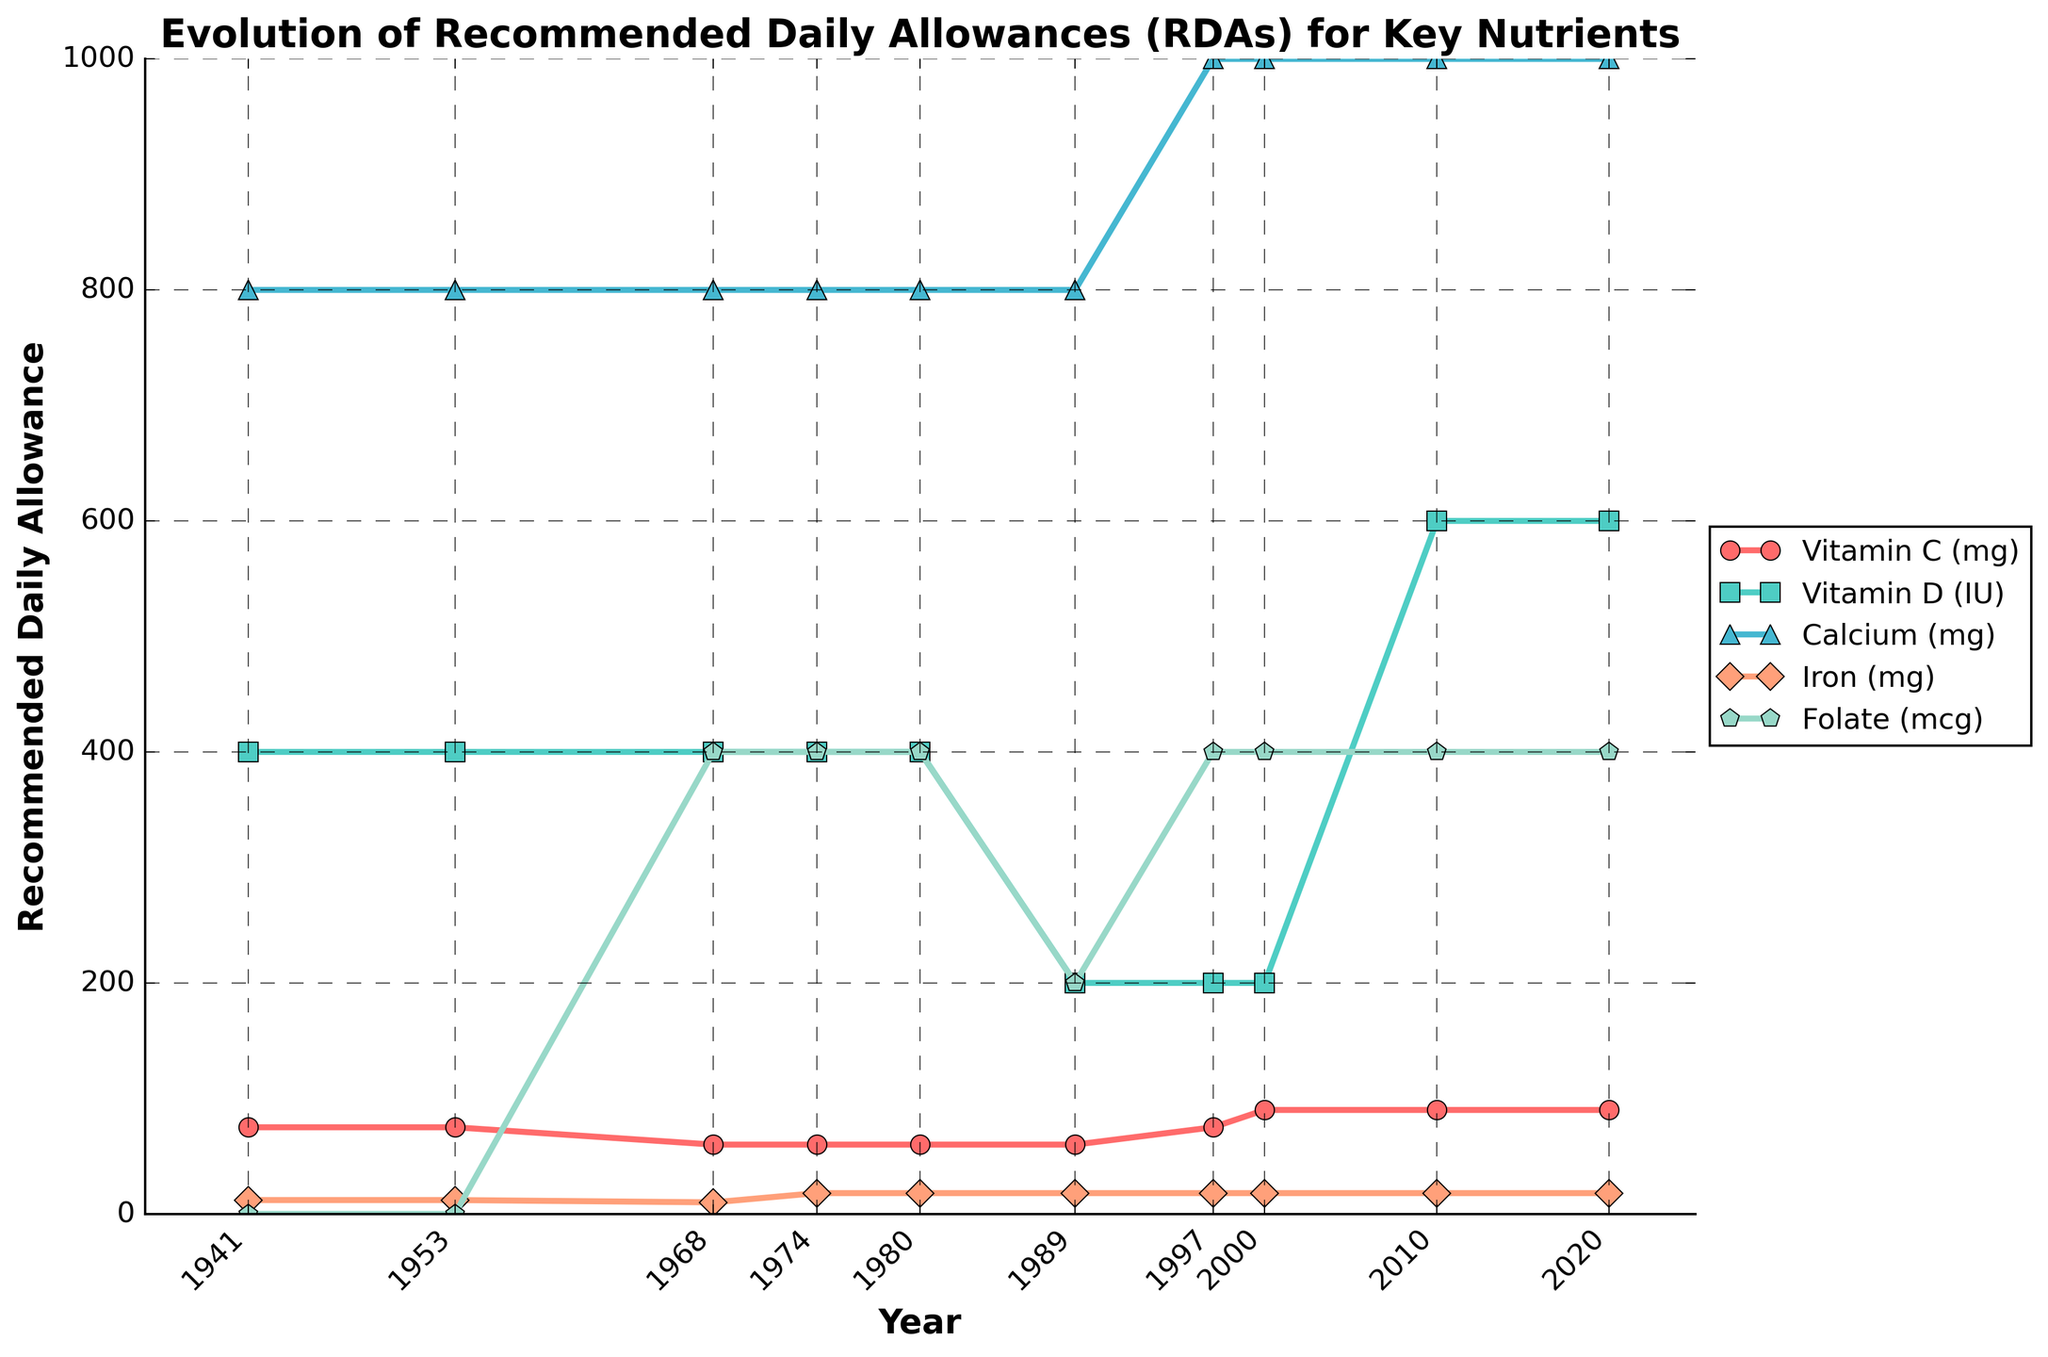What nutrient experienced the highest increase in its RDA over the years? To find which nutrient experienced the highest increase in its RDA, look at the starting and ending values for each nutrient and calculate the difference. Vitamin D increased from 400 IU to 600 IU (increase of 200 IU), Calcium went from 800 mg to 1000 mg (increase of 200 mg), Vitamin C increased from 75 mg to 90 mg (increase of 15 mg), and Folate increased from 0 mcg to 400 mcg (increase of 400 mcg).
Answer: Folate Which vitamin's RDA remained the same from 1941 to 1953? Look at the values for each vitamin in the years 1941 and 1953. The values for Vitamin C remained the same at 75 mg in both years.
Answer: Vitamin C When did the RDA for Vitamin D experience its first significant decrease? Observe the values for Vitamin D over the years. The RDA for Vitamin D decreased from 400 IU in 1980 to 200 IU in 1989.
Answer: 1989 Which nutrient had no initially recommended RDA in 1941 but had its RDA introduced later? Compare the values for each nutrient in 1941 and subsequent years. Folate had no RDA in 1941 but an RDA of 400 mcg was introduced in 1968.
Answer: Folate Which nutrient showed the same RDA values from 1997 to 2020? Observe the RDA values for each nutrient from 1997 to 2020. Both Calcium and Iron showed consistent values during these years.
Answer: Calcium, Iron In which decade did the RDA for Vitamin C change from below 75 mg to above 75 mg? Examine the RDA values for Vitamin C over the decades. The RDA for Vitamin C was below 75 mg in the 1960s and 1980s but increased to above 75 mg in 1997.
Answer: 1990s How many times did the RDA for Iron change from 1941 to 2020? Track the RDA values for Iron across different years. The values changed three times: from 12 mg to 10 mg in 1968, from 10 mg to 18 mg in 1974, and stayed at 18 mg onward.
Answer: 3 Which nutrient had the most stable RDA over the years? Identify the nutrient that had minimal changes in its RDA over the years. Calcium remained at 800 mg consistently from 1941 to 1989, and then 1000 mg from 1997 onward. This indicates high stability.
Answer: Calcium 